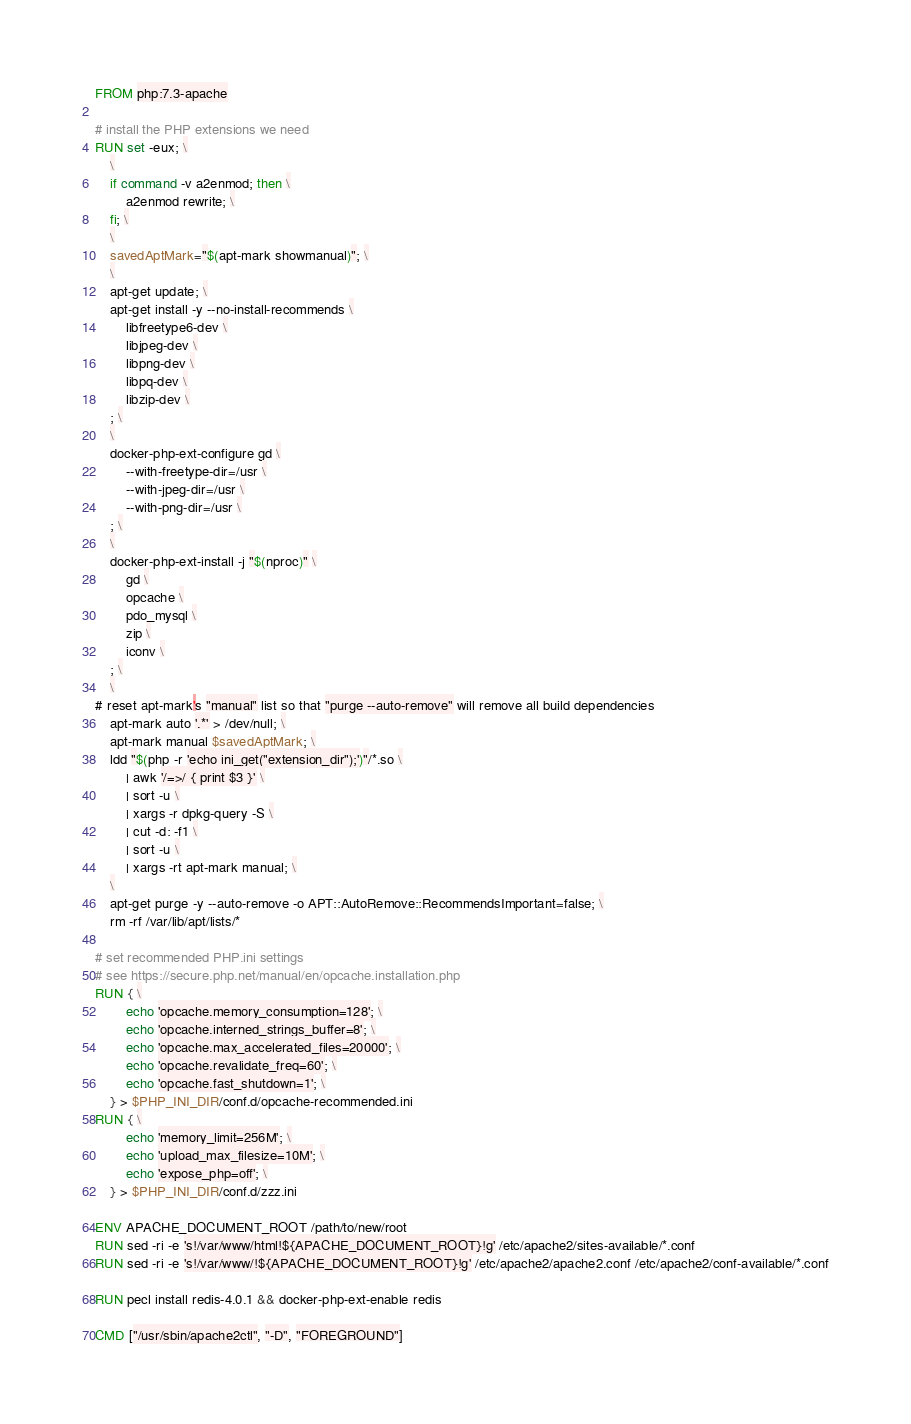Convert code to text. <code><loc_0><loc_0><loc_500><loc_500><_Dockerfile_>FROM php:7.3-apache

# install the PHP extensions we need
RUN set -eux; \
	\
	if command -v a2enmod; then \
		a2enmod rewrite; \
	fi; \
	\
	savedAptMark="$(apt-mark showmanual)"; \
	\
	apt-get update; \
	apt-get install -y --no-install-recommends \
		libfreetype6-dev \
		libjpeg-dev \
		libpng-dev \
		libpq-dev \
		libzip-dev \
	; \
	\
	docker-php-ext-configure gd \
		--with-freetype-dir=/usr \
		--with-jpeg-dir=/usr \
		--with-png-dir=/usr \
	; \
	\
	docker-php-ext-install -j "$(nproc)" \
		gd \
		opcache \
		pdo_mysql \
		zip \
        iconv \
	; \
	\
# reset apt-mark's "manual" list so that "purge --auto-remove" will remove all build dependencies
	apt-mark auto '.*' > /dev/null; \
	apt-mark manual $savedAptMark; \
	ldd "$(php -r 'echo ini_get("extension_dir");')"/*.so \
		| awk '/=>/ { print $3 }' \
		| sort -u \
		| xargs -r dpkg-query -S \
		| cut -d: -f1 \
		| sort -u \
		| xargs -rt apt-mark manual; \
	\
	apt-get purge -y --auto-remove -o APT::AutoRemove::RecommendsImportant=false; \
	rm -rf /var/lib/apt/lists/*

# set recommended PHP.ini settings
# see https://secure.php.net/manual/en/opcache.installation.php
RUN { \
		echo 'opcache.memory_consumption=128'; \
		echo 'opcache.interned_strings_buffer=8'; \
		echo 'opcache.max_accelerated_files=20000'; \
		echo 'opcache.revalidate_freq=60'; \
		echo 'opcache.fast_shutdown=1'; \
	} > $PHP_INI_DIR/conf.d/opcache-recommended.ini
RUN { \
		echo 'memory_limit=256M'; \
		echo 'upload_max_filesize=10M'; \
		echo 'expose_php=off'; \
	} > $PHP_INI_DIR/conf.d/zzz.ini

ENV APACHE_DOCUMENT_ROOT /path/to/new/root
RUN sed -ri -e 's!/var/www/html!${APACHE_DOCUMENT_ROOT}!g' /etc/apache2/sites-available/*.conf
RUN sed -ri -e 's!/var/www/!${APACHE_DOCUMENT_ROOT}!g' /etc/apache2/apache2.conf /etc/apache2/conf-available/*.conf

RUN pecl install redis-4.0.1 && docker-php-ext-enable redis

CMD ["/usr/sbin/apache2ctl", "-D", "FOREGROUND"]
</code> 